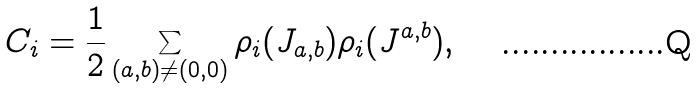Convert formula to latex. <formula><loc_0><loc_0><loc_500><loc_500>C _ { i } = \frac { 1 } { 2 } \sum _ { ( a , b ) \neq ( 0 , 0 ) } \rho _ { i } ( J _ { a , b } ) \rho _ { i } ( J ^ { a , b } ) ,</formula> 